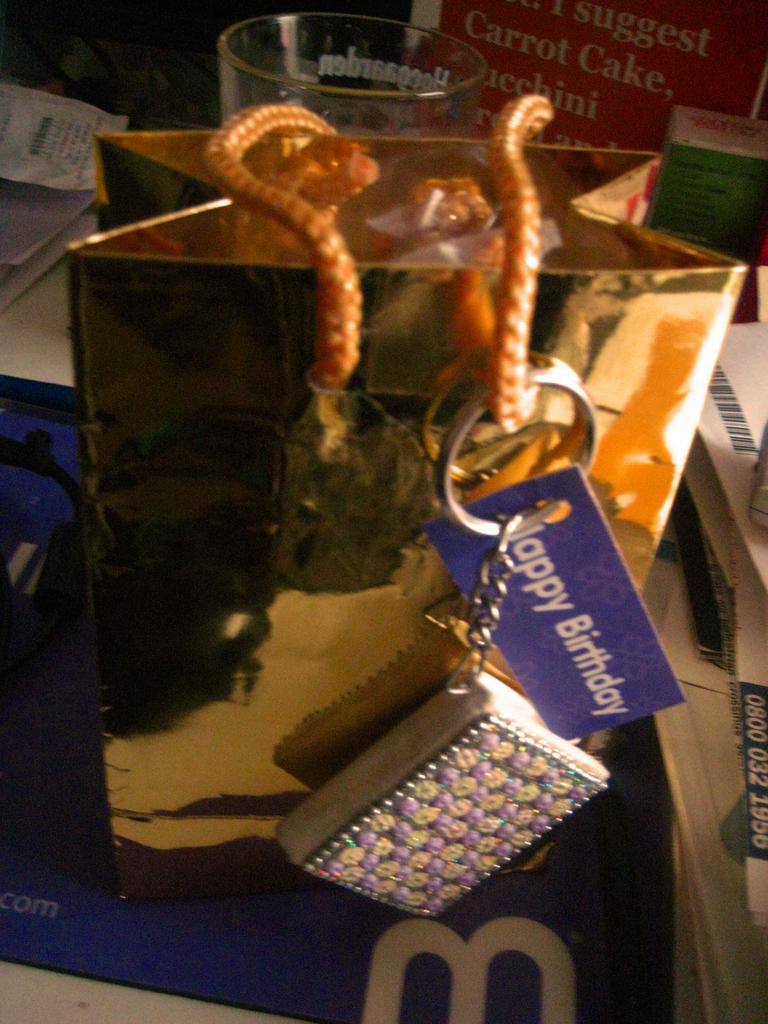What is the main object in the center of the image? There is a table in the center of the image. What items can be seen on the table? Papers, a wallet, a key, a golden color paper bag, banners, bill paper, a box, and a glass are visible on the table. Is there any furniture near the table? Yes, a chair is near the table. What other objects are present on the table? There are other objects on the table, but their specific details are not mentioned in the facts. What direction are the giants walking in the image? There are no giants present in the image. Is there a zoo visible in the image? There is no mention of a zoo in the image. 